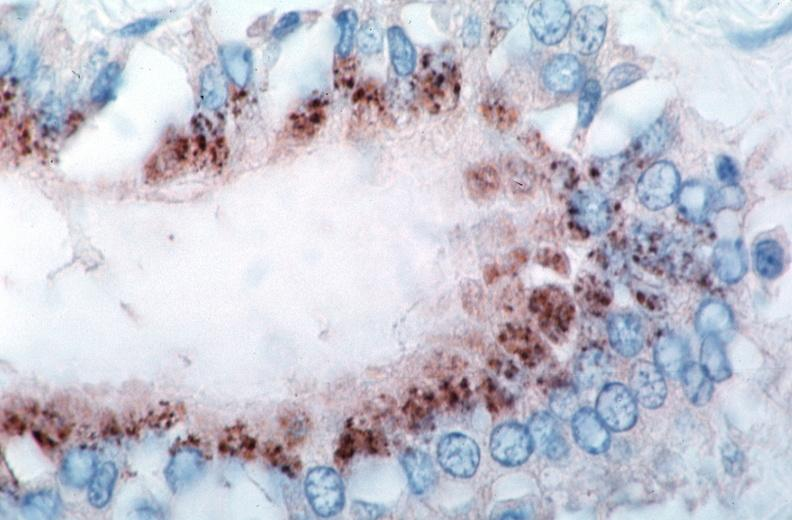what is present?
Answer the question using a single word or phrase. Cardiovascular 